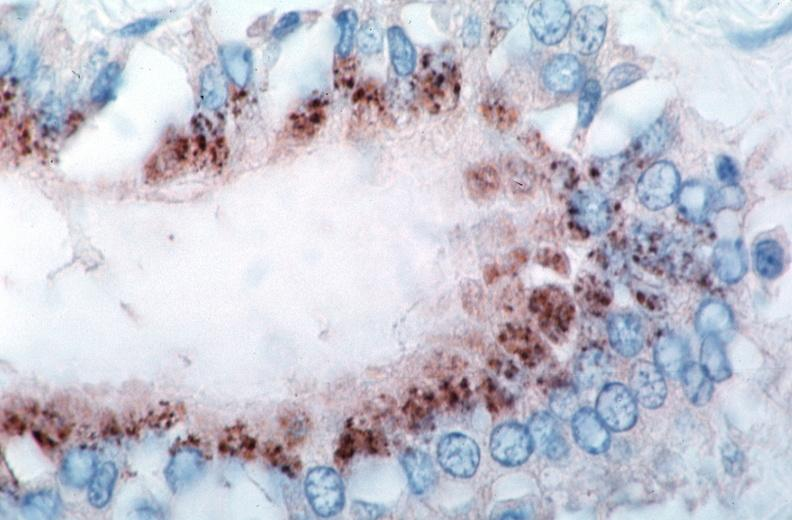what is present?
Answer the question using a single word or phrase. Cardiovascular 